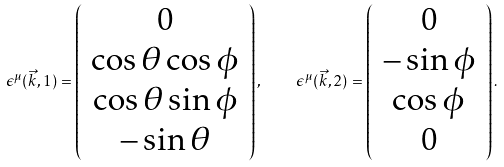<formula> <loc_0><loc_0><loc_500><loc_500>\epsilon ^ { \mu } ( \vec { k } , 1 ) = \left ( \begin{array} { c } 0 \\ \cos \theta \cos \phi \\ \cos \theta \sin \phi \\ - \sin \theta \end{array} \right ) , \quad \epsilon ^ { \mu } ( \vec { k } , 2 ) = \left ( \begin{array} { c } 0 \\ - \sin \phi \\ \cos \phi \\ 0 \end{array} \right ) .</formula> 